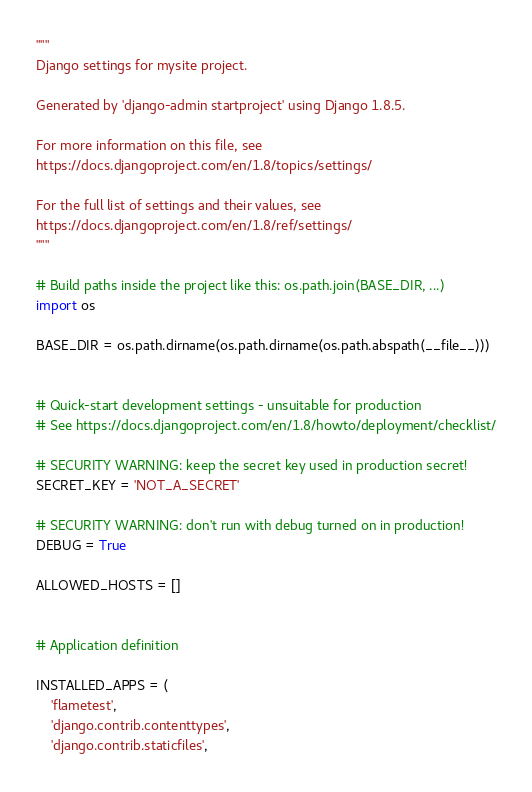<code> <loc_0><loc_0><loc_500><loc_500><_Python_>"""
Django settings for mysite project.

Generated by 'django-admin startproject' using Django 1.8.5.

For more information on this file, see
https://docs.djangoproject.com/en/1.8/topics/settings/

For the full list of settings and their values, see
https://docs.djangoproject.com/en/1.8/ref/settings/
"""

# Build paths inside the project like this: os.path.join(BASE_DIR, ...)
import os

BASE_DIR = os.path.dirname(os.path.dirname(os.path.abspath(__file__)))


# Quick-start development settings - unsuitable for production
# See https://docs.djangoproject.com/en/1.8/howto/deployment/checklist/

# SECURITY WARNING: keep the secret key used in production secret!
SECRET_KEY = 'NOT_A_SECRET'

# SECURITY WARNING: don't run with debug turned on in production!
DEBUG = True

ALLOWED_HOSTS = []


# Application definition

INSTALLED_APPS = (
    'flametest',
    'django.contrib.contenttypes',
    'django.contrib.staticfiles',</code> 